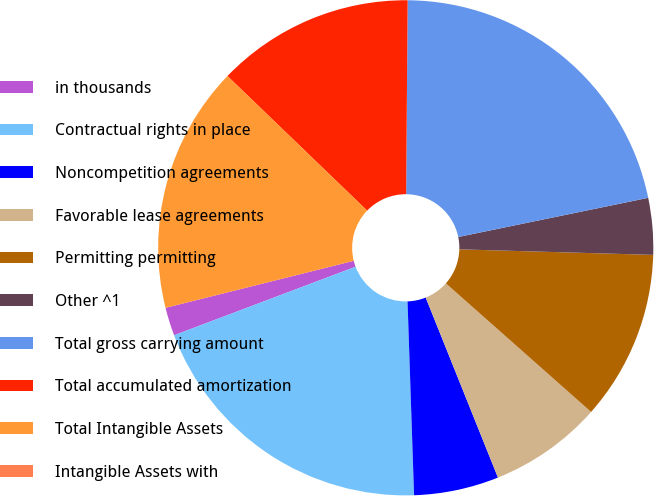Convert chart to OTSL. <chart><loc_0><loc_0><loc_500><loc_500><pie_chart><fcel>in thousands<fcel>Contractual rights in place<fcel>Noncompetition agreements<fcel>Favorable lease agreements<fcel>Permitting permitting<fcel>Other ^1<fcel>Total gross carrying amount<fcel>Total accumulated amortization<fcel>Total Intangible Assets<fcel>Intangible Assets with<nl><fcel>1.85%<fcel>19.79%<fcel>5.54%<fcel>7.39%<fcel>11.08%<fcel>3.69%<fcel>21.64%<fcel>12.92%<fcel>16.1%<fcel>0.0%<nl></chart> 